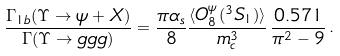<formula> <loc_0><loc_0><loc_500><loc_500>\frac { \Gamma _ { 1 b } ( \Upsilon \to \psi + X ) } { \Gamma ( \Upsilon \to g g g ) } = \frac { \pi \alpha _ { s } } { 8 } \frac { \langle O ^ { \psi } _ { 8 } ( ^ { 3 } S _ { 1 } ) \rangle } { m _ { c } ^ { 3 } } \, \frac { 0 . 5 7 1 } { \pi ^ { 2 } - 9 } \, .</formula> 